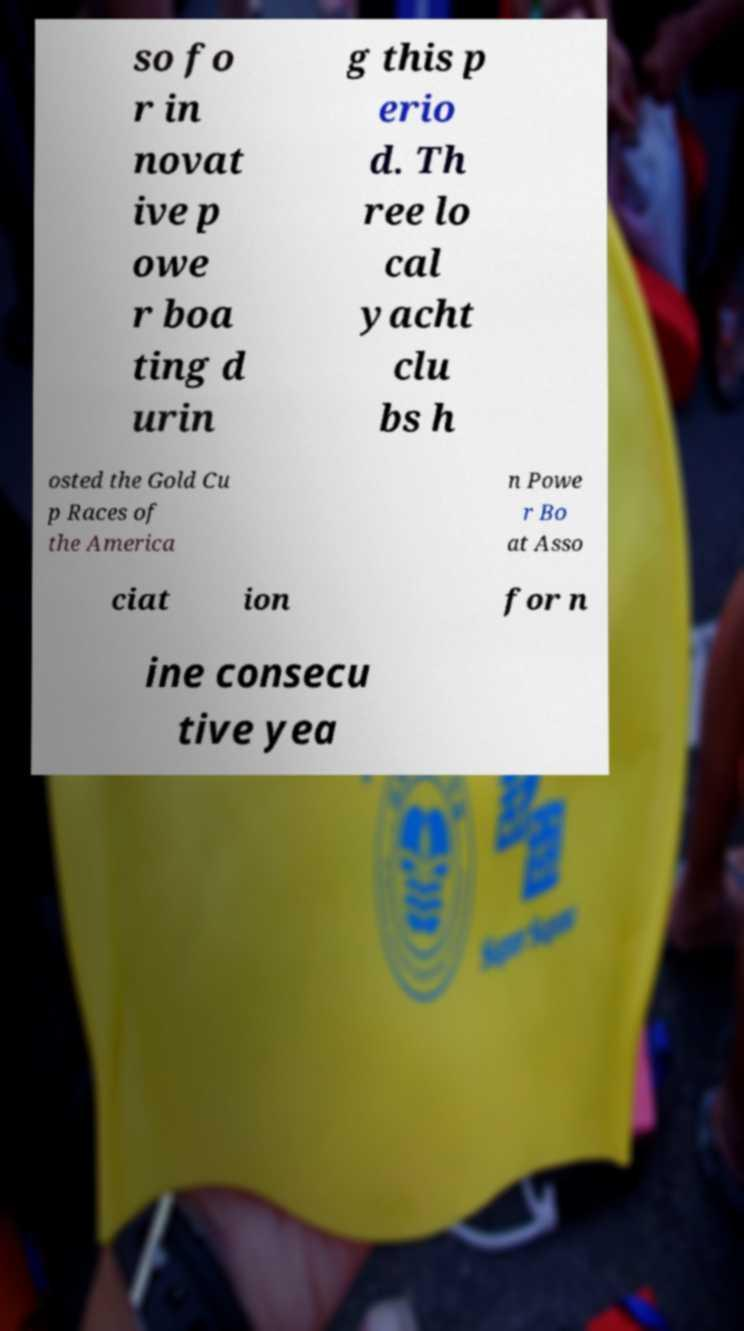What messages or text are displayed in this image? I need them in a readable, typed format. so fo r in novat ive p owe r boa ting d urin g this p erio d. Th ree lo cal yacht clu bs h osted the Gold Cu p Races of the America n Powe r Bo at Asso ciat ion for n ine consecu tive yea 